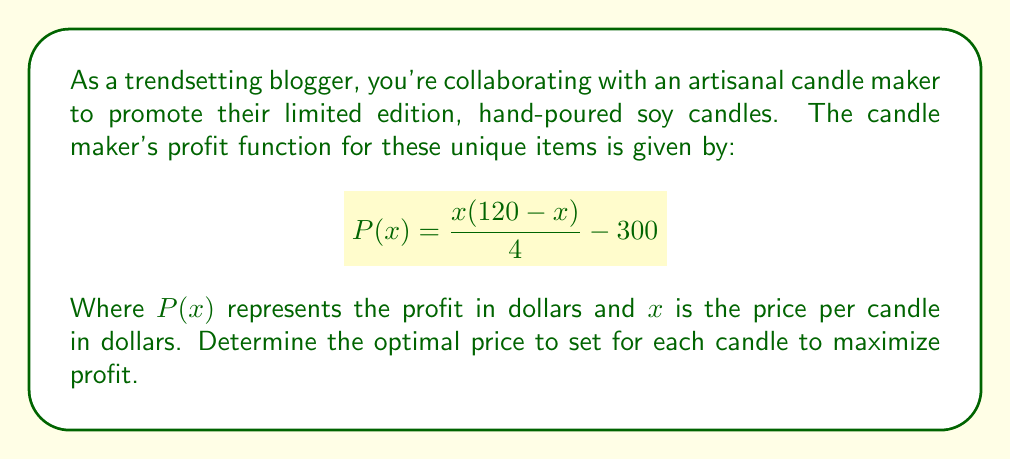What is the answer to this math problem? To find the optimal price, we need to maximize the profit function. This occurs at the vertex of the quadratic function in the numerator. Let's solve this step-by-step:

1) The profit function is a rational function:
   $$P(x) = \frac{x(120-x)}{4} - 300$$

2) Expand the numerator:
   $$P(x) = \frac{120x - x^2}{4} - 300$$

3) To find the vertex, we use the formula $x = -\frac{b}{2a}$ where $a$ and $b$ are coefficients of the quadratic function in the numerator:
   $$\frac{-b}{2a} = \frac{-120}{2(-1)} = 60$$

4) The optimal price is therefore $60 per candle.

5) We can verify this by testing values on either side of 60:
   At $x = 59$: $P(59) = \frac{59(120-59)}{4} - 300 = 900.25$
   At $x = 60$: $P(60) = \frac{60(120-60)}{4} - 300 = 900$
   At $x = 61$: $P(61) = \frac{61(120-61)}{4} - 300 = 899.75$

This confirms that the profit is maximized at $x = 60$.
Answer: $60 per candle 